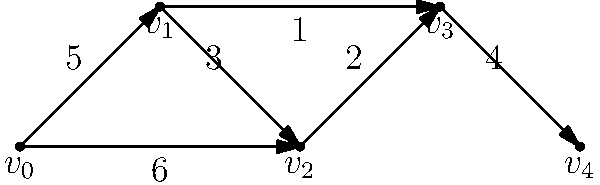Given the directed graph representing network traffic flow, where vertices represent nodes and edge weights represent data transfer rates in Gbps, what is the maximum flow from $v_0$ to $v_4$ assuming no bottlenecks at the nodes? To find the maximum flow from $v_0$ to $v_4$, we need to identify all possible paths and their corresponding capacities:

1. Path 1: $v_0 \rightarrow v_1 \rightarrow v_2 \rightarrow v_3 \rightarrow v_4$
   Capacity: $\min(5, 3, 2, 4) = 2$ Gbps

2. Path 2: $v_0 \rightarrow v_1 \rightarrow v_3 \rightarrow v_4$
   Capacity: $\min(5, 1, 4) = 1$ Gbps

3. Path 3: $v_0 \rightarrow v_2 \rightarrow v_3 \rightarrow v_4$
   Capacity: $\min(6, 2, 4) = 2$ Gbps

The maximum flow is the sum of the capacities of all these paths:

$\text{Maximum Flow} = 2 + 1 + 2 = 5$ Gbps

This approach assumes that the nodes do not have any capacity constraints and can handle any amount of incoming and outgoing traffic.
Answer: 5 Gbps 